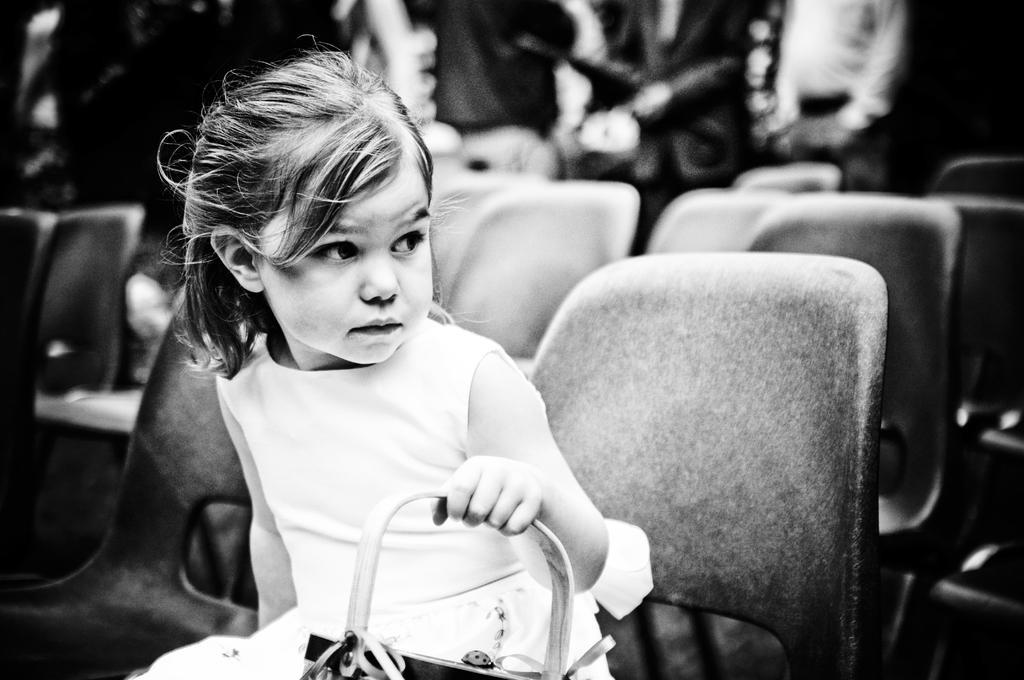How would you summarize this image in a sentence or two? In this image I can see a girl sitting on a chair. In the background I can see few more chairs. 